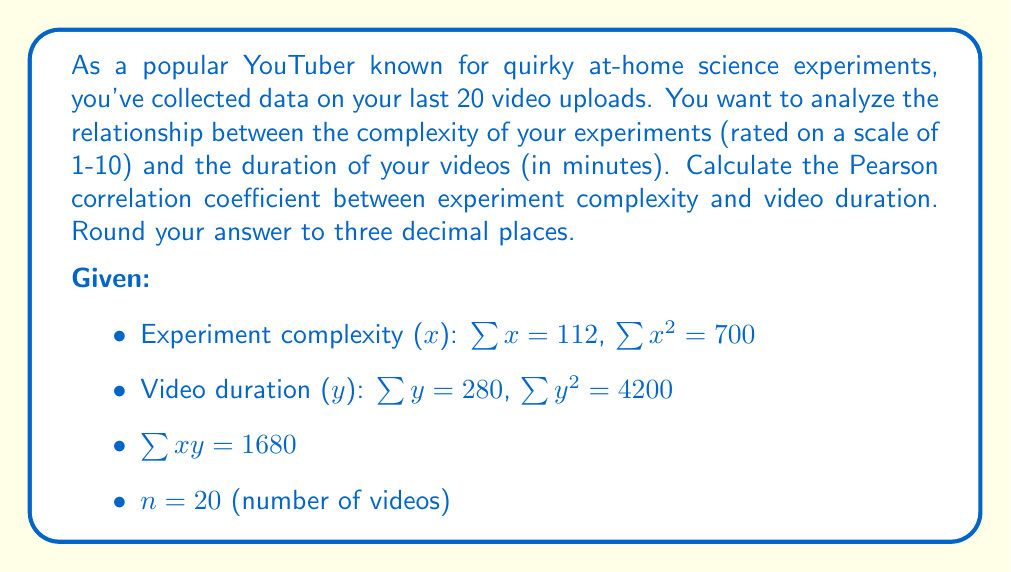Can you solve this math problem? To calculate the Pearson correlation coefficient ($r$), we'll use the formula:

$$r = \frac{n\sum xy - \sum x \sum y}{\sqrt{[n\sum x^2 - (\sum x)^2][n\sum y^2 - (\sum y)^2]}}$$

Let's break this down step-by-step:

1) Calculate $n\sum xy$:
   $20 \times 1680 = 33600$

2) Calculate $\sum x \sum y$:
   $112 \times 280 = 31360$

3) Calculate the numerator:
   $33600 - 31360 = 2240$

4) For the denominator, first calculate the $x$ term:
   $n\sum x^2 - (\sum x)^2 = 20 \times 700 - 112^2 = 14000 - 12544 = 1456$

5) Calculate the $y$ term:
   $n\sum y^2 - (\sum y)^2 = 20 \times 4200 - 280^2 = 84000 - 78400 = 5600$

6) Multiply these terms:
   $1456 \times 5600 = 8153600$

7) Take the square root:
   $\sqrt{8153600} = 2855.45$

8) Now, put it all together:
   $r = \frac{2240}{2855.45} = 0.7844$

9) Rounding to three decimal places:
   $r = 0.784$
Answer: 0.784 